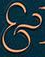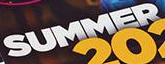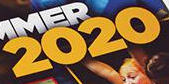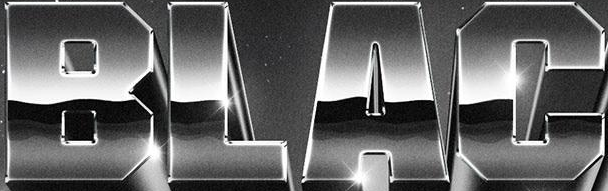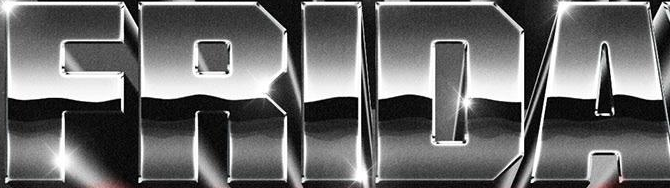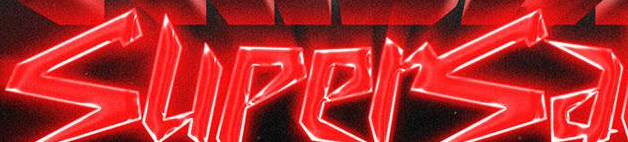What text appears in these images from left to right, separated by a semicolon? &; SUMMER; 2020; BLAC; FRIDA; supersa 